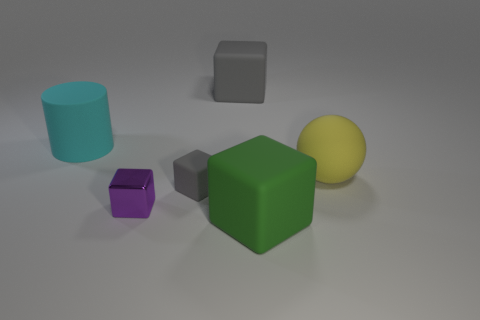Imagine these objects are part of a game, what could be the objective involving the large green cube? In this imaginative game scenario, the large green cube may be the central piece that players must protect or maneuver into a specific region of the play area. Its vibrant color sets it apart, indicating its importance, while the other shapes could act as obstacles or secondary objectives that either assist or hinder the player's progress in safeguarding the green cube. 